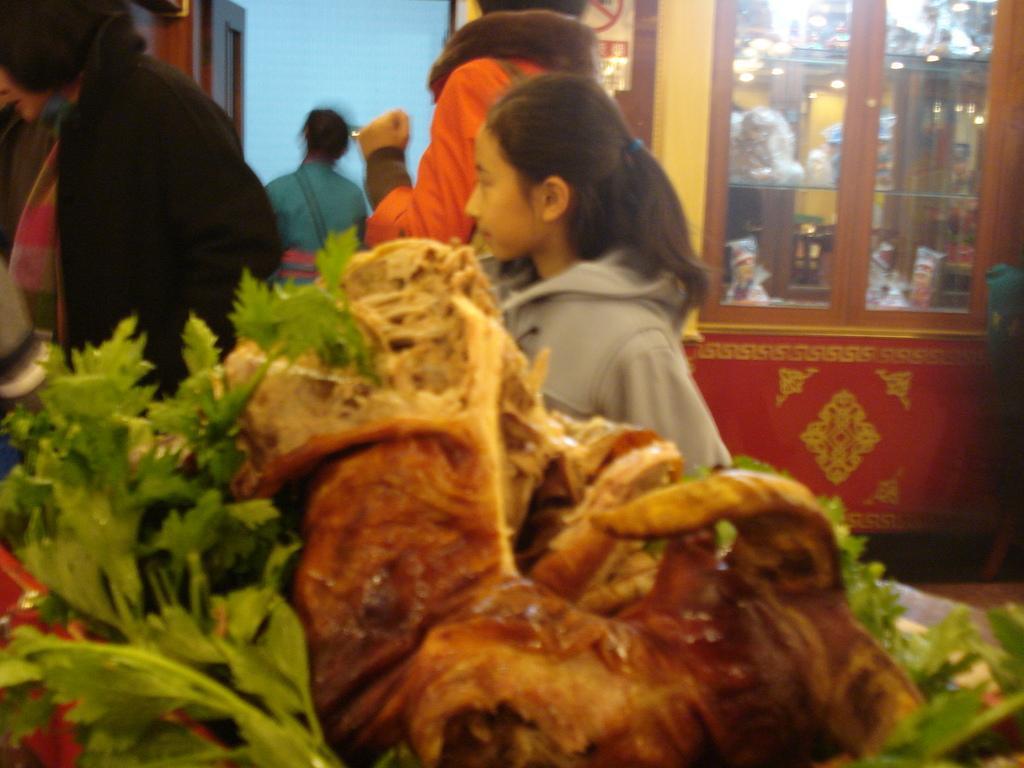Could you give a brief overview of what you see in this image? This image is taken indoors. In the background there is a wall with a door and there is a cupboard with a few shelves and there are many things on the shelves. In the middle of the image a few people are standing on the floor. At the bottom of the image there is a tray with meat and green leaves on it. 